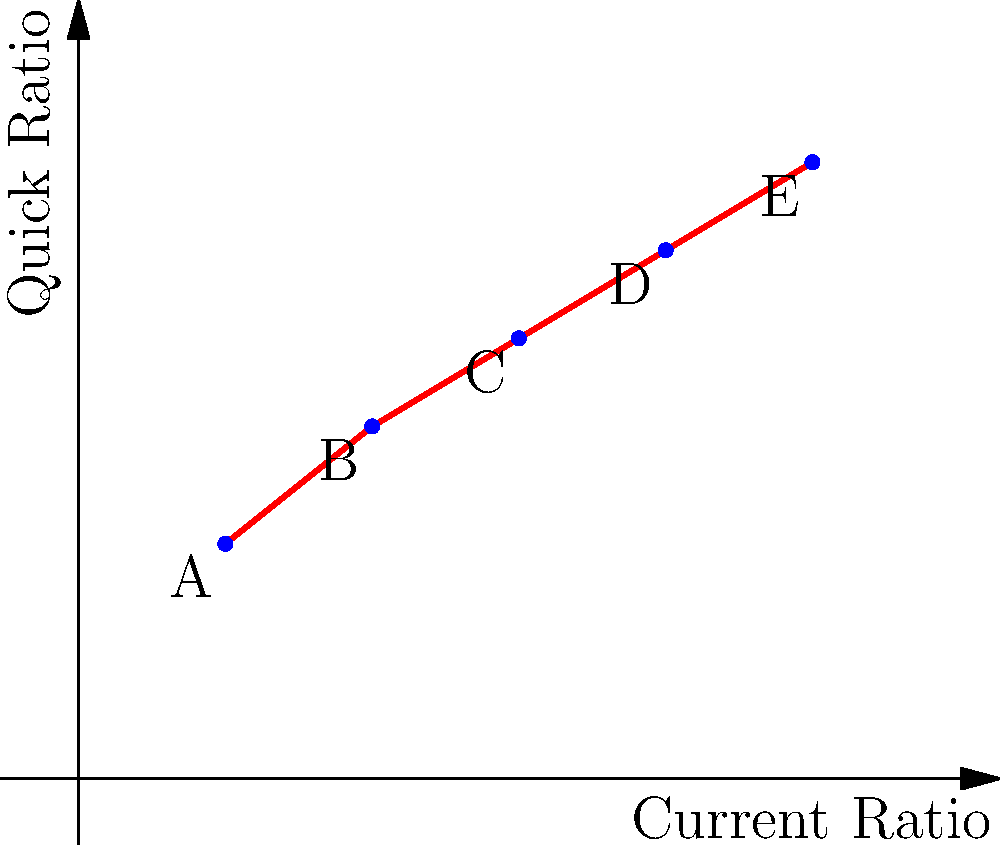The graph shows the Current Ratio and Quick Ratio for five companies (A, B, C, D, and E) over a period. Based on this information, which company is likely to have the highest proportion of inventory in its current assets? To answer this question, we need to understand the relationship between the Current Ratio and Quick Ratio:

1. Current Ratio = (Current Assets) / (Current Liabilities)
2. Quick Ratio = (Current Assets - Inventory) / (Current Liabilities)

The difference between these ratios is the inclusion of inventory in the Current Ratio.

Step 1: Observe the graph. The x-axis represents the Current Ratio, and the y-axis represents the Quick Ratio.

Step 2: Compare the Current Ratio to the Quick Ratio for each company.
- Company A: Current Ratio ≈ 0.5, Quick Ratio ≈ 0.8
- Company B: Current Ratio ≈ 1.0, Quick Ratio ≈ 1.2
- Company C: Current Ratio ≈ 1.5, Quick Ratio ≈ 1.5
- Company D: Current Ratio ≈ 2.0, Quick Ratio ≈ 1.8
- Company E: Current Ratio ≈ 2.5, Quick Ratio ≈ 2.1

Step 3: Calculate the difference between Current Ratio and Quick Ratio for each company.
- Company A: 0.5 - 0.8 = -0.3 (anomaly, possibly due to negative working capital)
- Company B: 1.0 - 1.2 = -0.2 (anomaly, possibly due to negative working capital)
- Company C: 1.5 - 1.5 = 0
- Company D: 2.0 - 1.8 = 0.2
- Company E: 2.5 - 2.1 = 0.4

Step 4: The largest positive difference indicates the highest proportion of inventory in current assets.

Therefore, Company E has the largest gap between its Current Ratio and Quick Ratio, suggesting it has the highest proportion of inventory in its current assets.
Answer: Company E 